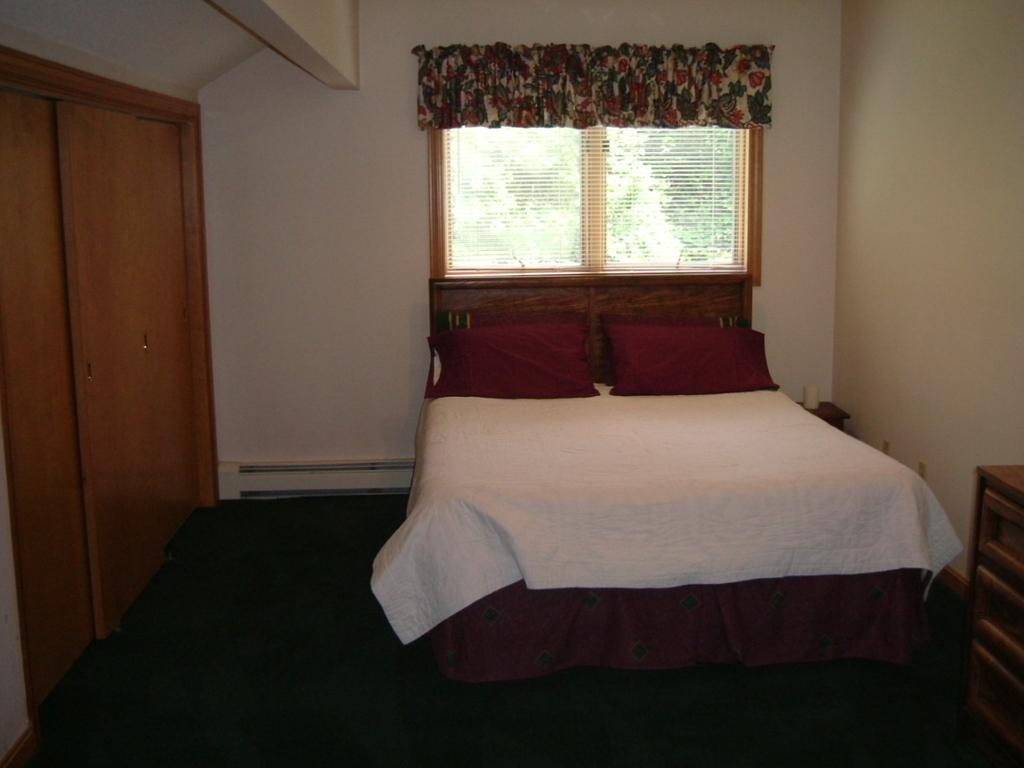What type of furniture can be seen in the room? There is a wardrobe in the room. What architectural feature is present in the room? There is a wall in the room. What allows natural light into the room? There is a window in the room. What is a common piece of furniture found in a bedroom? There is a bed in the room. What type of religion is practiced in the room? There is no indication of any religious practice in the room; it only contains a wardrobe, wall, window, and bed. How much profit can be made from the window in the room? There is no information about profit or any financial aspect related to the window in the room. 